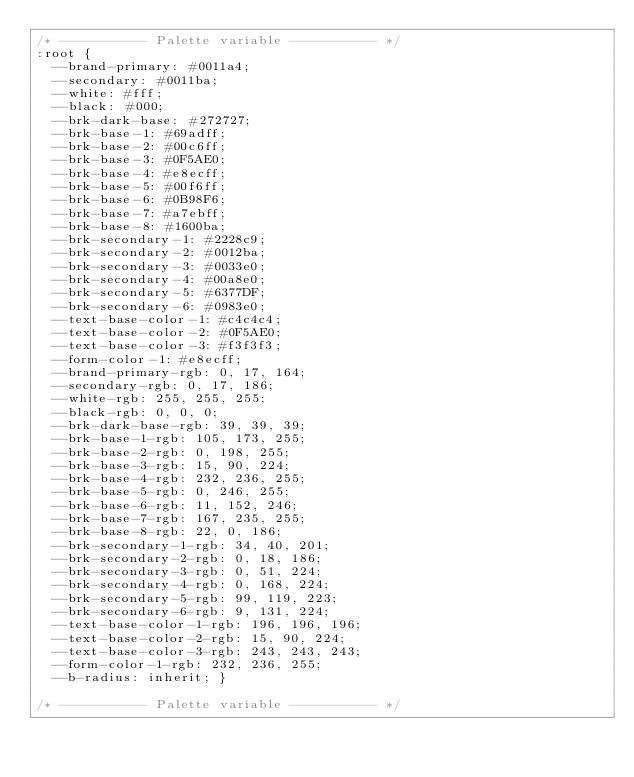Convert code to text. <code><loc_0><loc_0><loc_500><loc_500><_CSS_>/* ----------- Palette variable ----------- */
:root {
  --brand-primary: #0011a4;
  --secondary: #0011ba;
  --white: #fff;
  --black: #000;
  --brk-dark-base: #272727;
  --brk-base-1: #69adff;
  --brk-base-2: #00c6ff;
  --brk-base-3: #0F5AE0;
  --brk-base-4: #e8ecff;
  --brk-base-5: #00f6ff;
  --brk-base-6: #0B98F6;
  --brk-base-7: #a7ebff;
  --brk-base-8: #1600ba;
  --brk-secondary-1: #2228c9;
  --brk-secondary-2: #0012ba;
  --brk-secondary-3: #0033e0;
  --brk-secondary-4: #00a8e0;
  --brk-secondary-5: #6377DF;
  --brk-secondary-6: #0983e0;
  --text-base-color-1: #c4c4c4;
  --text-base-color-2: #0F5AE0;
  --text-base-color-3: #f3f3f3;
  --form-color-1: #e8ecff;
  --brand-primary-rgb: 0, 17, 164;
  --secondary-rgb: 0, 17, 186;
  --white-rgb: 255, 255, 255;
  --black-rgb: 0, 0, 0;
  --brk-dark-base-rgb: 39, 39, 39;
  --brk-base-1-rgb: 105, 173, 255;
  --brk-base-2-rgb: 0, 198, 255;
  --brk-base-3-rgb: 15, 90, 224;
  --brk-base-4-rgb: 232, 236, 255;
  --brk-base-5-rgb: 0, 246, 255;
  --brk-base-6-rgb: 11, 152, 246;
  --brk-base-7-rgb: 167, 235, 255;
  --brk-base-8-rgb: 22, 0, 186;
  --brk-secondary-1-rgb: 34, 40, 201;
  --brk-secondary-2-rgb: 0, 18, 186;
  --brk-secondary-3-rgb: 0, 51, 224;
  --brk-secondary-4-rgb: 0, 168, 224;
  --brk-secondary-5-rgb: 99, 119, 223;
  --brk-secondary-6-rgb: 9, 131, 224;
  --text-base-color-1-rgb: 196, 196, 196;
  --text-base-color-2-rgb: 15, 90, 224;
  --text-base-color-3-rgb: 243, 243, 243;
  --form-color-1-rgb: 232, 236, 255;
  --b-radius: inherit; }

/* ----------- Palette variable ----------- */
</code> 